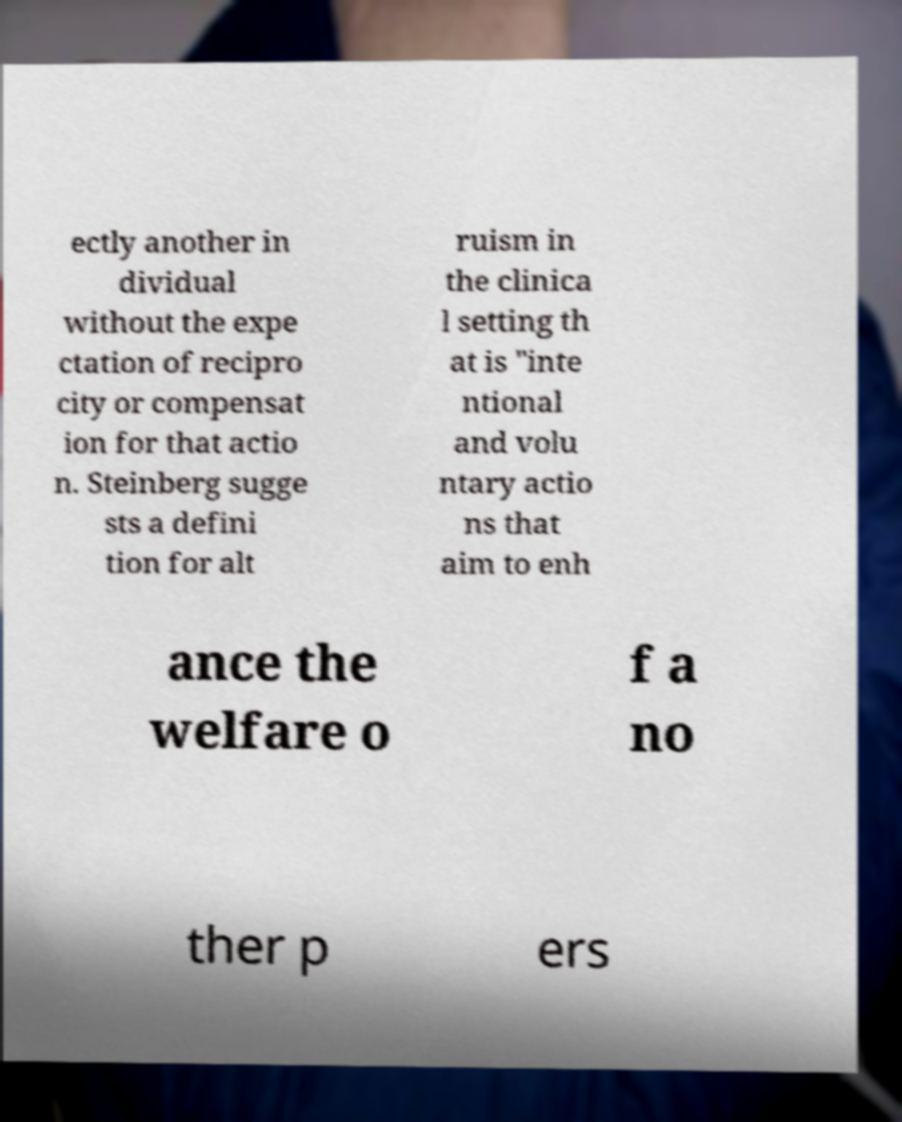There's text embedded in this image that I need extracted. Can you transcribe it verbatim? ectly another in dividual without the expe ctation of recipro city or compensat ion for that actio n. Steinberg sugge sts a defini tion for alt ruism in the clinica l setting th at is "inte ntional and volu ntary actio ns that aim to enh ance the welfare o f a no ther p ers 